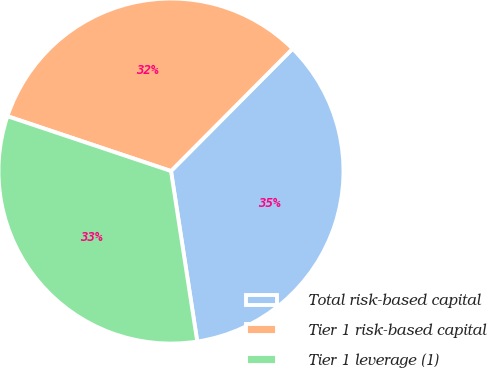Convert chart to OTSL. <chart><loc_0><loc_0><loc_500><loc_500><pie_chart><fcel>Total risk-based capital<fcel>Tier 1 risk-based capital<fcel>Tier 1 leverage (1)<nl><fcel>35.11%<fcel>32.3%<fcel>32.58%<nl></chart> 